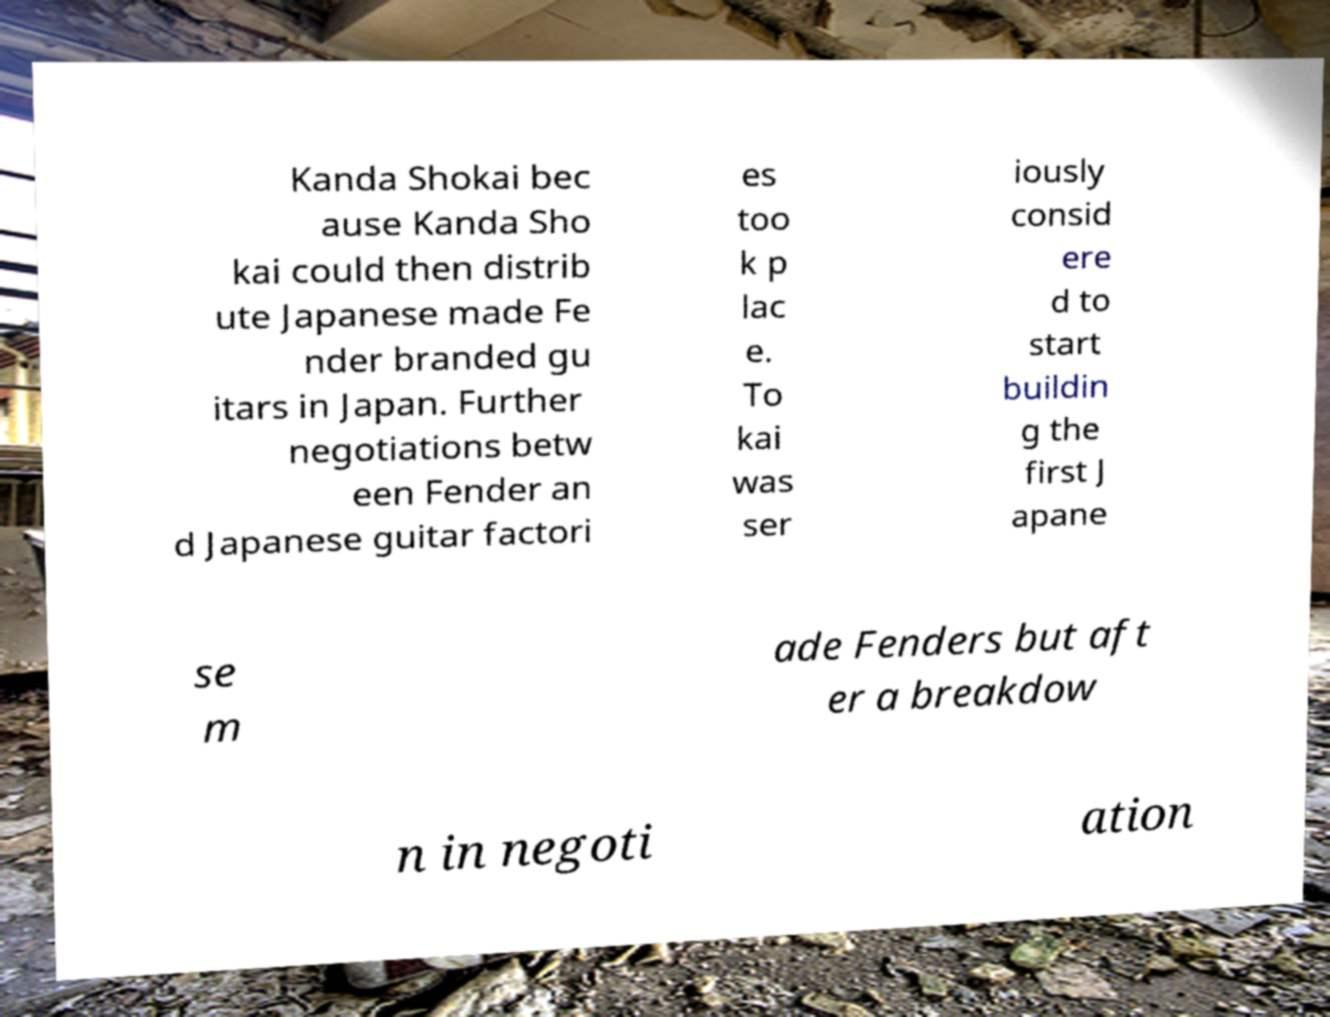There's text embedded in this image that I need extracted. Can you transcribe it verbatim? Kanda Shokai bec ause Kanda Sho kai could then distrib ute Japanese made Fe nder branded gu itars in Japan. Further negotiations betw een Fender an d Japanese guitar factori es too k p lac e. To kai was ser iously consid ere d to start buildin g the first J apane se m ade Fenders but aft er a breakdow n in negoti ation 